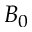<formula> <loc_0><loc_0><loc_500><loc_500>B _ { 0 }</formula> 